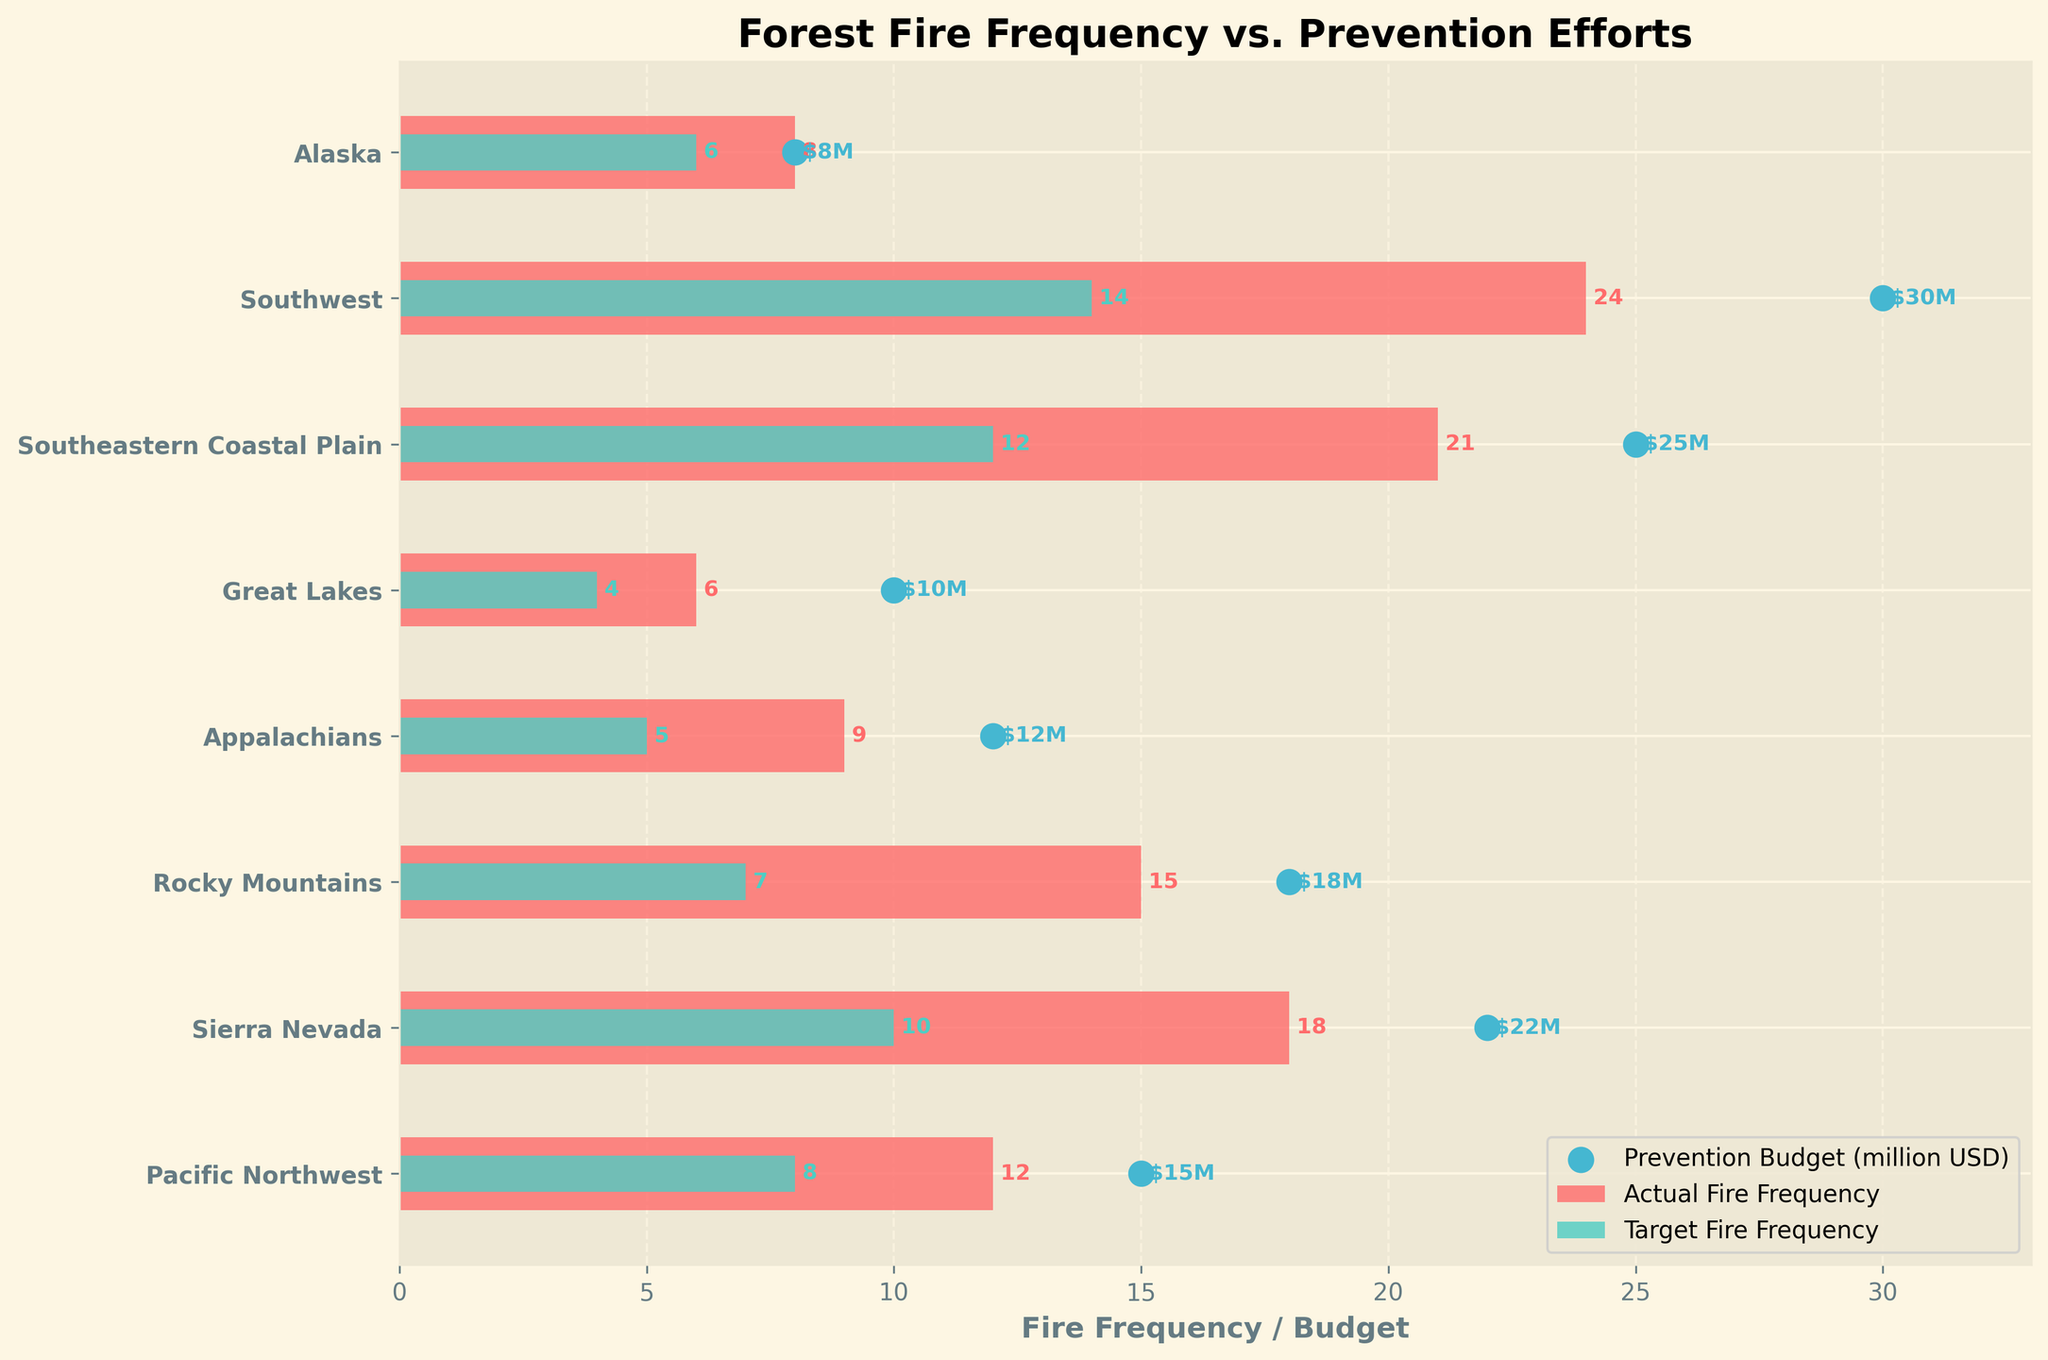What is the title of the chart? The title of the chart is typically written at the top center of the figure. By referring to this portion, we can easily identify the title.
Answer: Forest Fire Frequency vs. Prevention Efforts Which region has the highest actual fire frequency? Locate the actual fire frequency bars. The highest bar indicates the region with the highest frequency.
Answer: Southwest What is the target fire frequency for the Appalachian region? Identify the Appalachian region's row and look at the shorter bar, which represents the target fire frequency.
Answer: 5 How does the prevention budget correlate with the actual fire frequency in the Sierra Nevada region? For the Sierra Nevada, check the bullet chart’s red bar to see the actual fire frequency and the corresponding blue scatter point for the budget. Comparing them gives insight into correlation.
Answer: Higher budget with high fire frequency What is the difference between the actual and target fire frequency in the Rocky Mountains region? Find the actual and target fire frequencies for the Rocky Mountains region and subtract the target from the actual frequency.
Answer: 8 (15 - 7) Which region received the lowest prevention budget? Look at the scatter points and locate the one with the smallest value. Check its corresponding region label.
Answer: Alaska Compare the actual fire frequencies of the Pacific Northwest and the Great Lakes. Which is higher and by how much? Find the actual fire frequencies for both regions and compare them by subtraction.
Answer: Pacific Northwest is higher by 6 (12 - 6) What is the average actual fire frequency across all regions? Sum the actual fire frequencies of all regions and divide by the number of regions (8).
Answer: 14.125 [(12 + 18 + 15 + 9 + 6 + 21 + 24 + 8) / 8] Which region surpasses its target fire frequency the most, and by how much? For each region, subtract the target fire frequency from the actual fire frequency and determine which difference is the largest.
Answer: Southwest by 10 (24 - 14) What is the prevention budget for regions with an actual fire frequency greater than 10? Identify regions with actual fire frequency > 10 and check their corresponding scatter points for the prevention budget.
Answer: Pacific Northwest: 15, Sierra Nevada: 22, Rocky Mountains: 18, Southeastern Coastal Plain: 25, Southwest: 30 